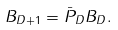<formula> <loc_0><loc_0><loc_500><loc_500>B _ { D + 1 } = \bar { P } _ { D } B _ { D } .</formula> 